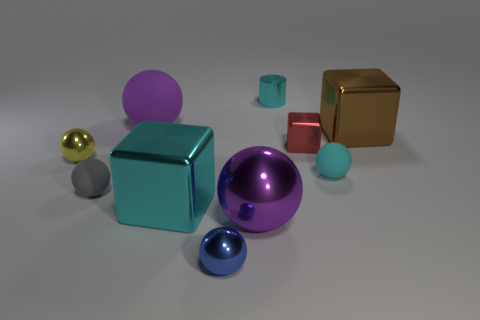Subtract 3 balls. How many balls are left? 3 Subtract all purple balls. How many balls are left? 4 Subtract all small gray balls. How many balls are left? 5 Subtract all red balls. Subtract all yellow cylinders. How many balls are left? 6 Subtract all cylinders. How many objects are left? 9 Add 6 big brown shiny blocks. How many big brown shiny blocks exist? 7 Subtract 1 brown cubes. How many objects are left? 9 Subtract all large purple metal spheres. Subtract all small yellow metallic spheres. How many objects are left? 8 Add 3 tiny gray balls. How many tiny gray balls are left? 4 